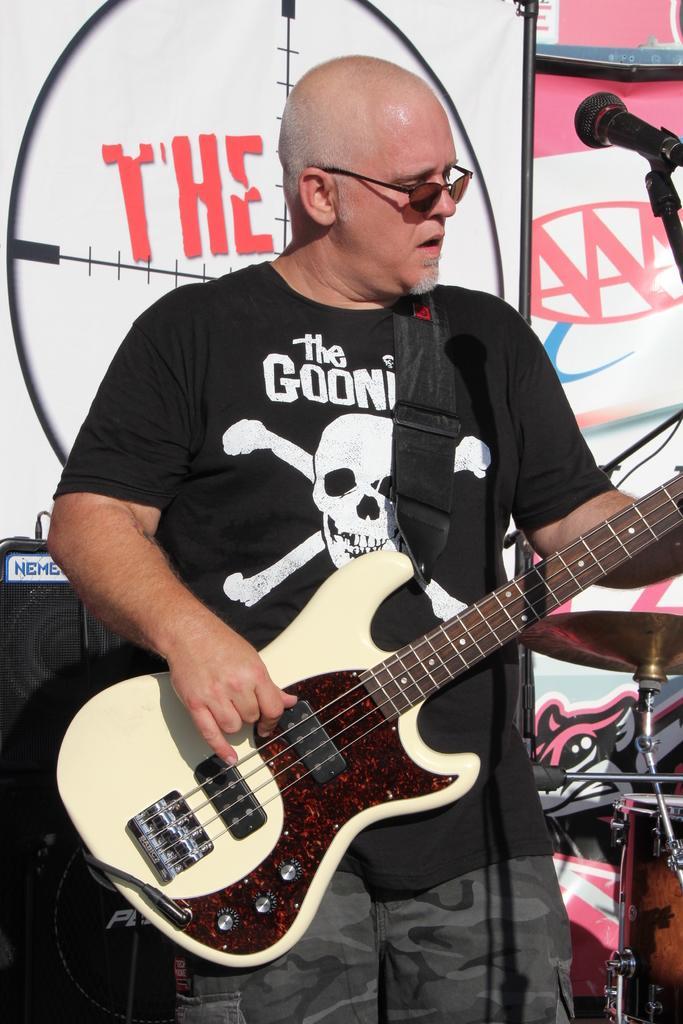Describe this image in one or two sentences. In the image we can see there is a man who is holding a guitar and in front of him there is a mike with stand. 